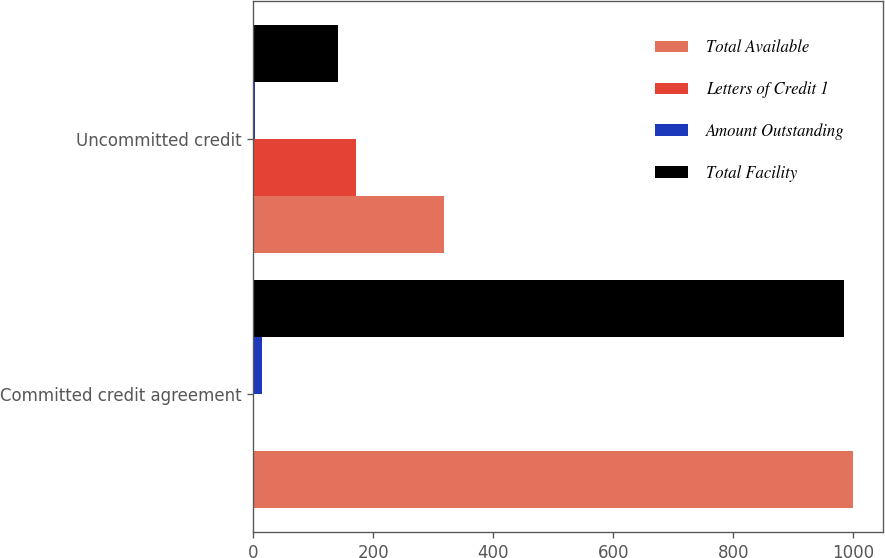<chart> <loc_0><loc_0><loc_500><loc_500><stacked_bar_chart><ecel><fcel>Committed credit agreement<fcel>Uncommitted credit<nl><fcel>Total Available<fcel>1000<fcel>317.2<nl><fcel>Letters of Credit 1<fcel>0<fcel>172.1<nl><fcel>Amount Outstanding<fcel>15.1<fcel>3.3<nl><fcel>Total Facility<fcel>984.9<fcel>141.8<nl></chart> 